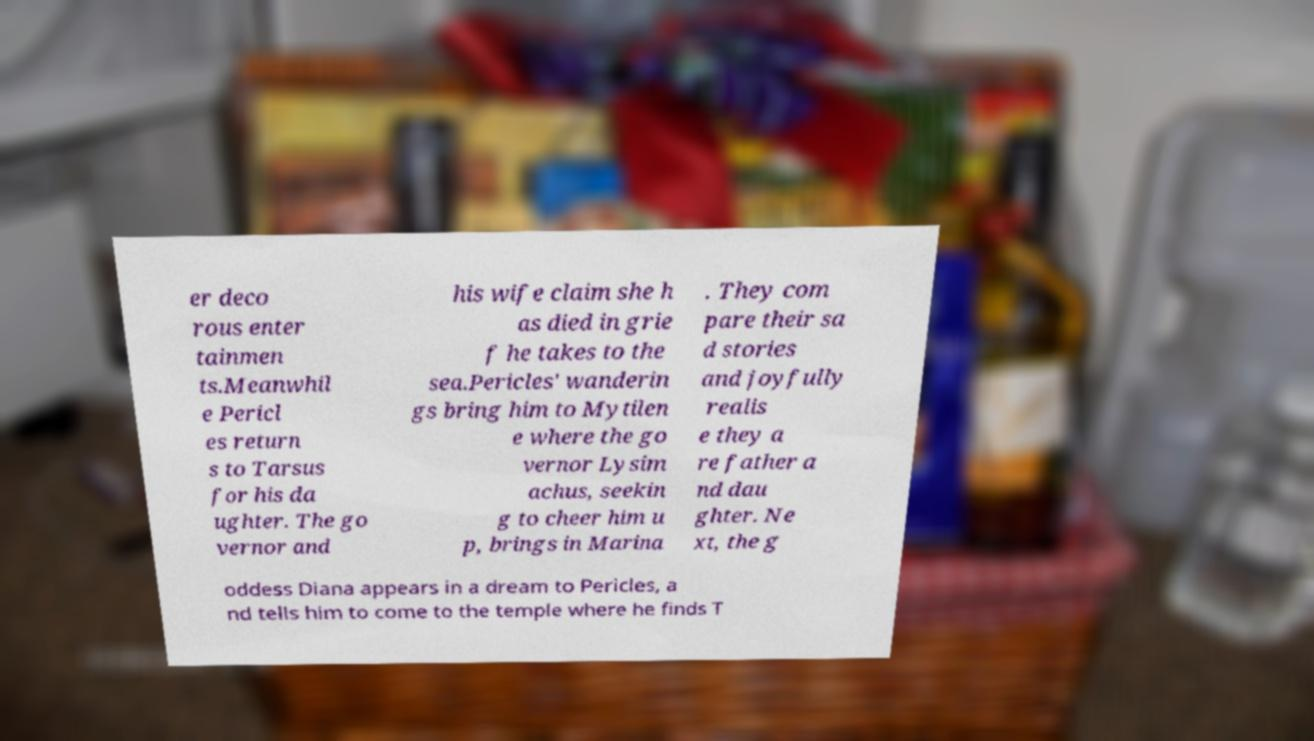Could you extract and type out the text from this image? er deco rous enter tainmen ts.Meanwhil e Pericl es return s to Tarsus for his da ughter. The go vernor and his wife claim she h as died in grie f he takes to the sea.Pericles' wanderin gs bring him to Mytilen e where the go vernor Lysim achus, seekin g to cheer him u p, brings in Marina . They com pare their sa d stories and joyfully realis e they a re father a nd dau ghter. Ne xt, the g oddess Diana appears in a dream to Pericles, a nd tells him to come to the temple where he finds T 